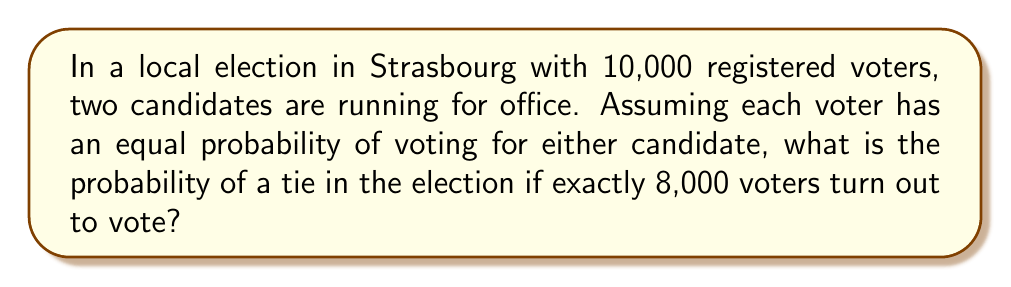Can you answer this question? Let's approach this step-by-step:

1) First, we need to understand what a tie means. In this case, it's when each candidate receives exactly 4,000 votes out of the 8,000 cast.

2) This is a problem of combinatorics. We can use the binomial distribution to solve it.

3) The probability of a specific outcome (like a tie) in a binomial distribution is given by:

   $$ P(X = k) = \binom{n}{k} p^k (1-p)^{n-k} $$

   Where:
   $n$ is the number of trials (voters in this case)
   $k$ is the number of successes (votes for one candidate)
   $p$ is the probability of success on each trial

4) In our case:
   $n = 8000$ (total voters)
   $k = 4000$ (votes for one candidate in case of a tie)
   $p = 0.5$ (probability of voting for either candidate)

5) Plugging these into our formula:

   $$ P(\text{Tie}) = \binom{8000}{4000} (0.5)^{4000} (0.5)^{4000} $$

6) Simplify:

   $$ P(\text{Tie}) = \binom{8000}{4000} (0.5)^{8000} $$

7) Calculate the binomial coefficient:

   $$ \binom{8000}{4000} = \frac{8000!}{4000!(8000-4000)!} = \frac{8000!}{(4000!)^2} $$

8) This is a very large number. Using a calculator or computer, we can compute this value.

9) The final probability is approximately 0.00562, or about 0.562%.
Answer: $0.00562$ or $0.562\%$ 